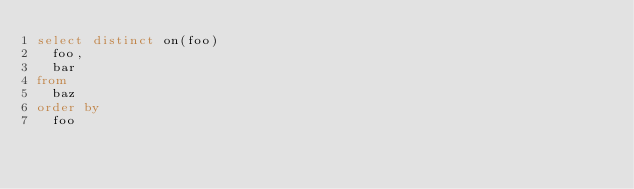<code> <loc_0><loc_0><loc_500><loc_500><_SQL_>select distinct on(foo)
  foo,
  bar
from
  baz
order by
  foo
</code> 